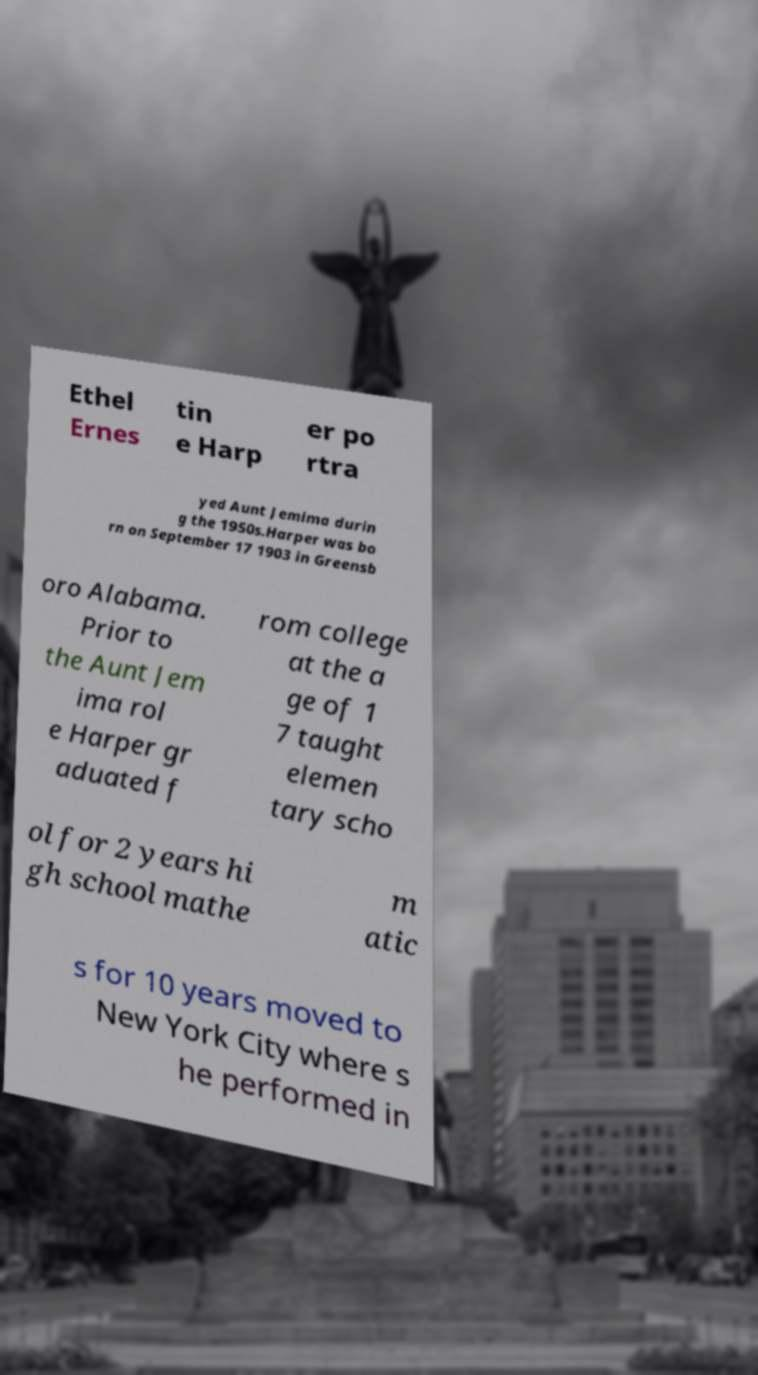Please identify and transcribe the text found in this image. Ethel Ernes tin e Harp er po rtra yed Aunt Jemima durin g the 1950s.Harper was bo rn on September 17 1903 in Greensb oro Alabama. Prior to the Aunt Jem ima rol e Harper gr aduated f rom college at the a ge of 1 7 taught elemen tary scho ol for 2 years hi gh school mathe m atic s for 10 years moved to New York City where s he performed in 